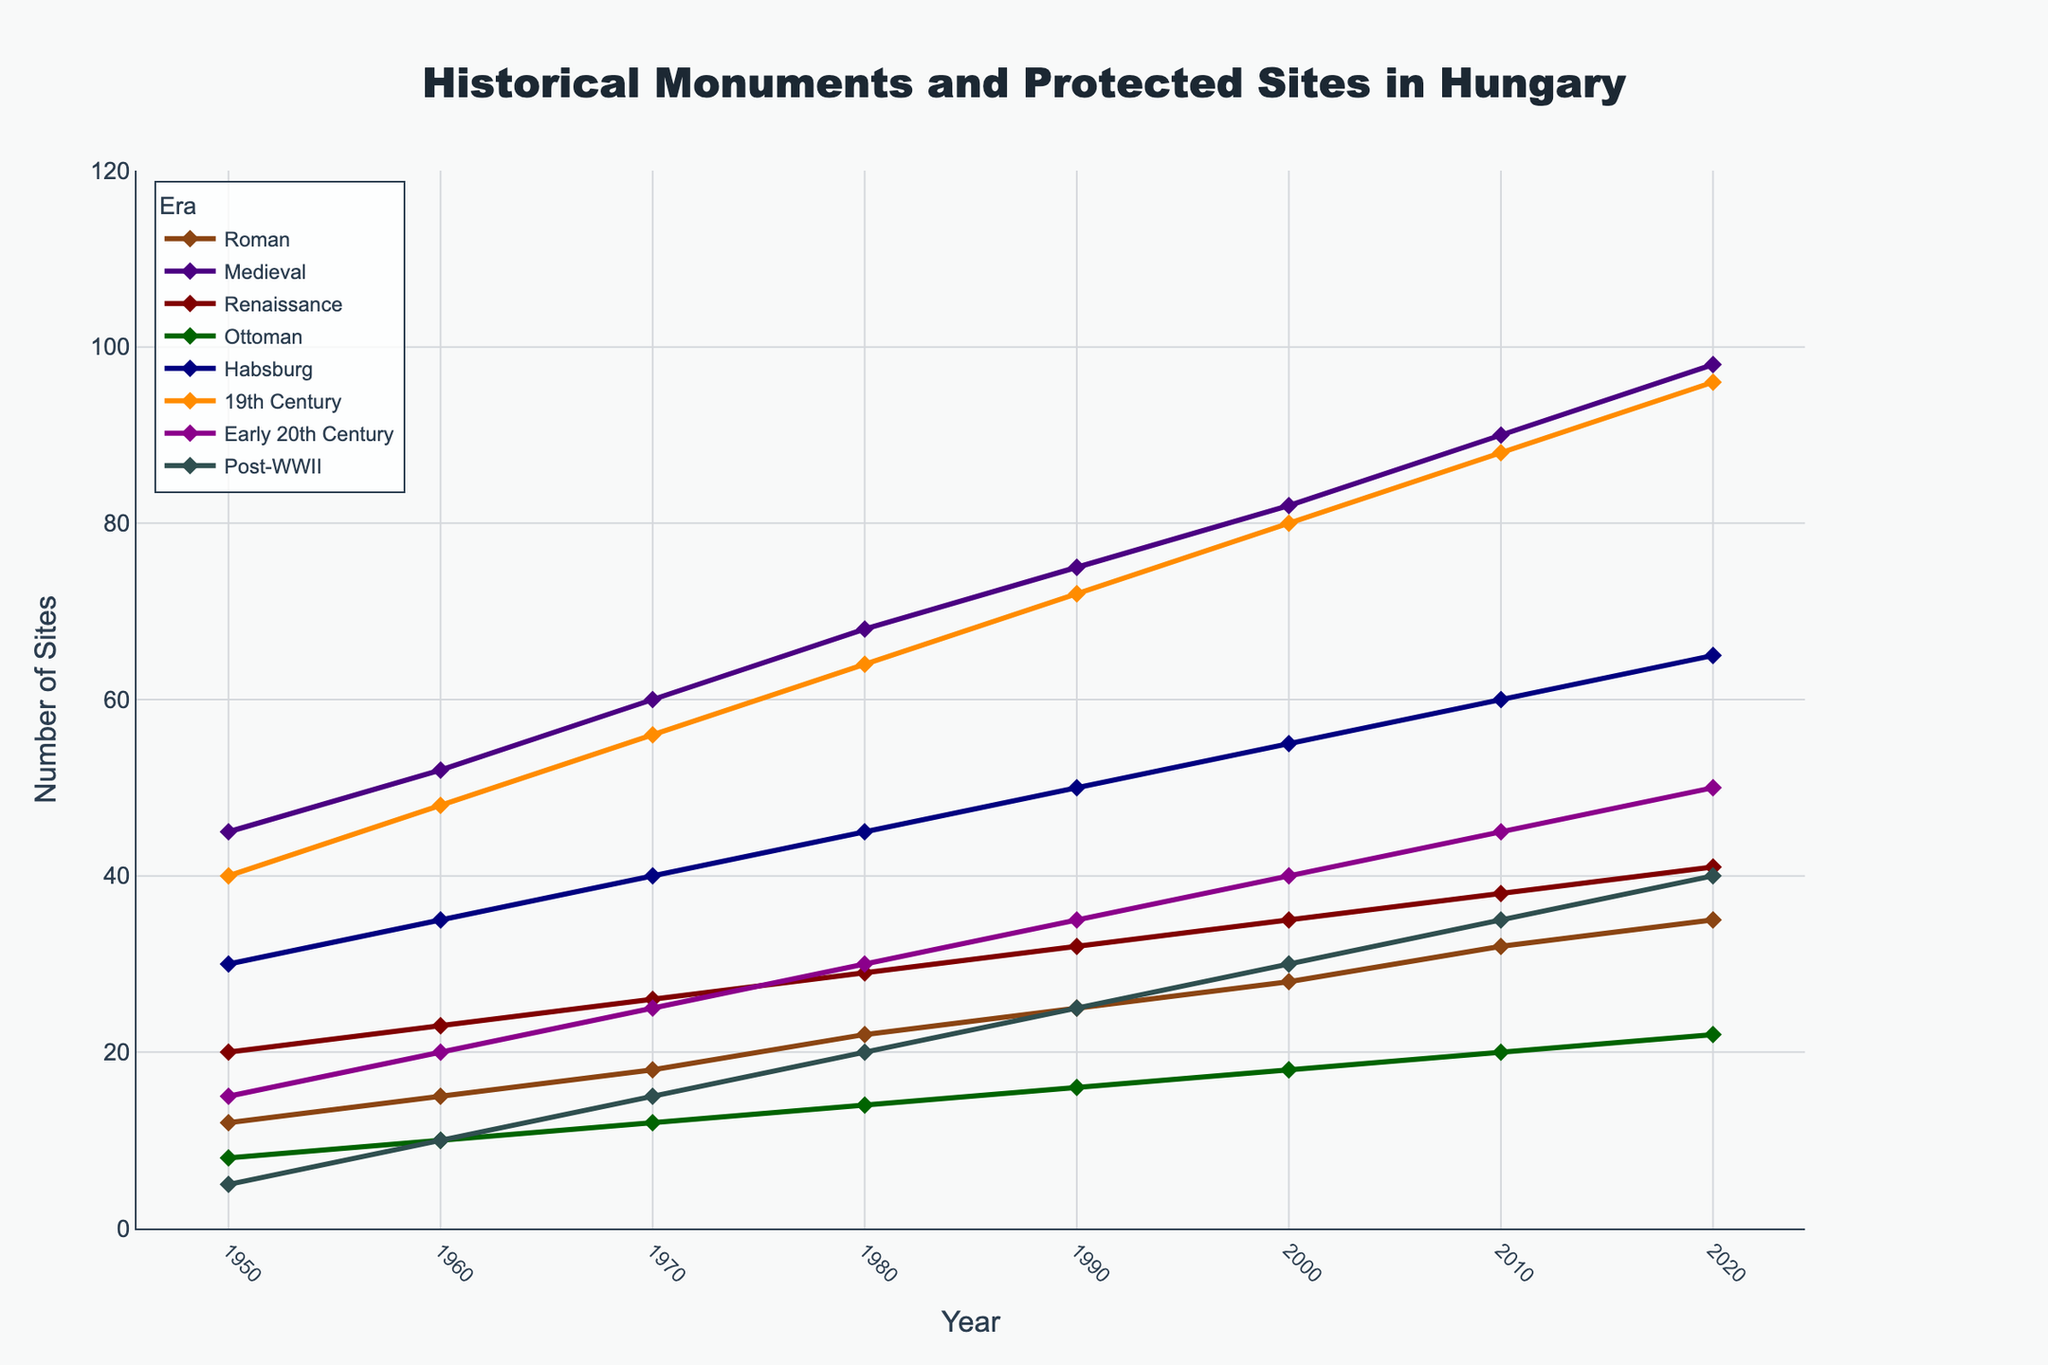What's the trend in the number of Medieval sites from 1950 to 2020? Look at the Medieval line in the chart from 1950 to 2020. The line shows a steady increase from 45 sites in 1950 to 98 sites in 2020.
Answer: Steady increase Which era had the highest number of protected sites in 1980? Check the 1980 data points on the y-axis and compare them across all eras. The Medieval era had the highest number of protected sites at 68.
Answer: Medieval What is the difference in the number of sites between 19th Century sites and Early 20th Century sites in 2020? In 2020, the 19th Century sites are at 96 and the Early 20th Century sites are at 50. Subtract 50 from 96.
Answer: 46 By how much did the number of Habsburg sites increase from 1950 to 2020? Look at the Habsburg data points: 30 in 1950 and 65 in 2020. Subtract 30 from 65.
Answer: 35 During which period did Roman sites see the most significant increase? Compare the slopes of the Roman line between each decade. The most significant increase is between 1950 and 1960, with an increase from 12 to 15.
Answer: 1950-1960 Which era shows the least change in the number of sites from 1950 to 2020? Look at the relative flatness of each line from 1950 to 2020. The Ottoman era shows the least change, from 8 in 1950 to 22 in 2020.
Answer: Ottoman What is the sum of the number of Medieval, Renaissance, and Habsburg sites in 1990? Look at the 1990 data: Medieval (75), Renaissance (32), Habsburg (50). Sum them up: 75 + 32 + 50.
Answer: 157 How does the number of Post-WWII sites in 2000 compare to the number of Roman sites in the same year? Check the 2000 data: Post-WWII (30), Roman (28).
Answer: Post-WWII is greater What is the average number of protected sites across all eras in 1970? Add the 1970 values for each era and divide by the number of eras (8). (18 + 60 + 26 + 12 + 40 + 56 + 25 + 15) / 8.
Answer: 31 What pattern is evident in the number of Renaissance sites from 1950 to 2020? Observe the Renaissance line; it shows a consistent, steady increase from 20 in 1950 to 41 in 2020.
Answer: Consistent increase 